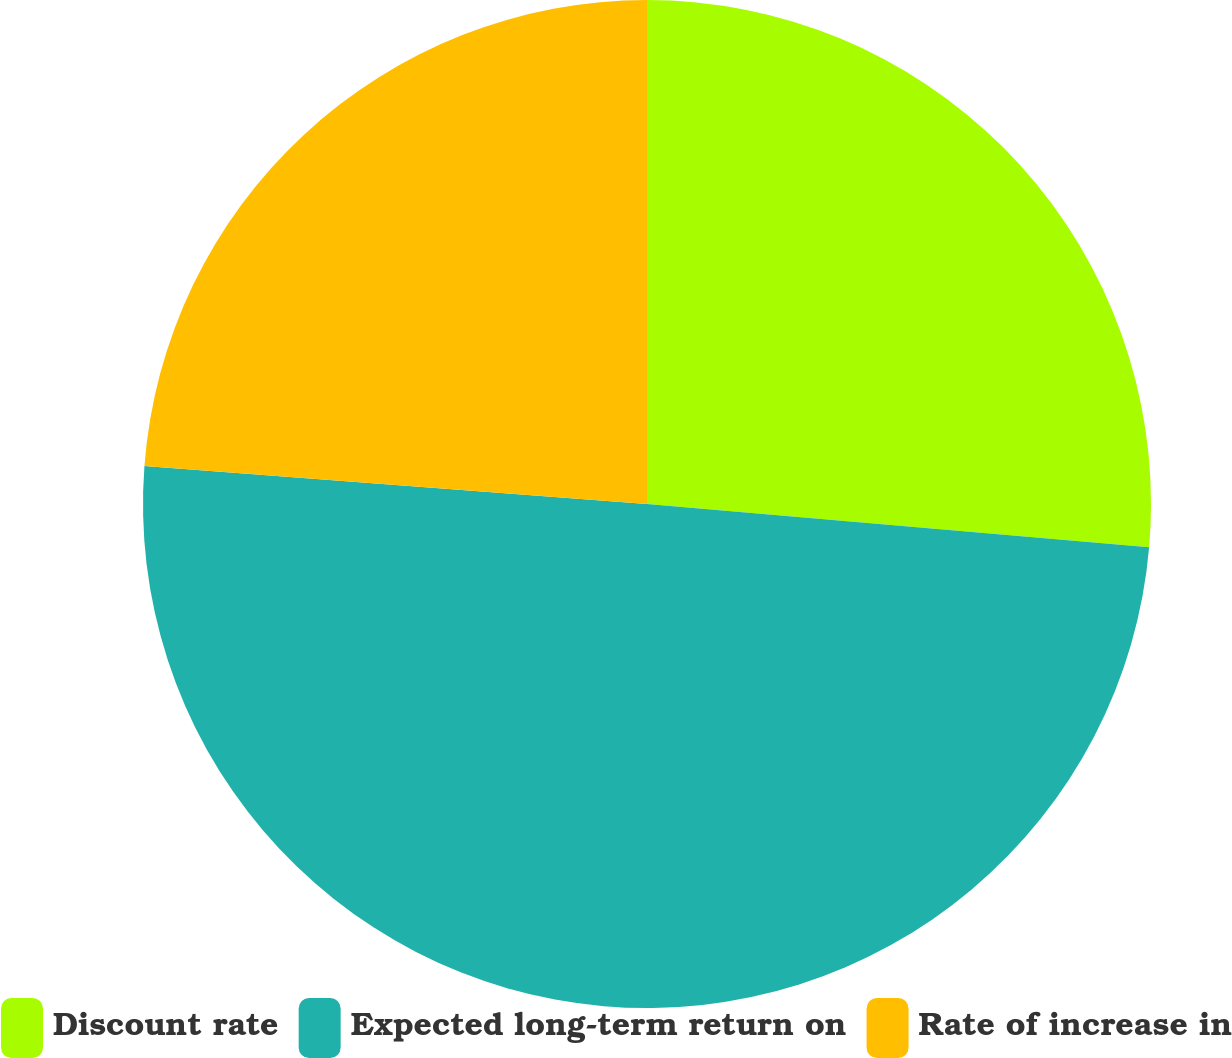Convert chart to OTSL. <chart><loc_0><loc_0><loc_500><loc_500><pie_chart><fcel>Discount rate<fcel>Expected long-term return on<fcel>Rate of increase in<nl><fcel>26.37%<fcel>49.83%<fcel>23.8%<nl></chart> 